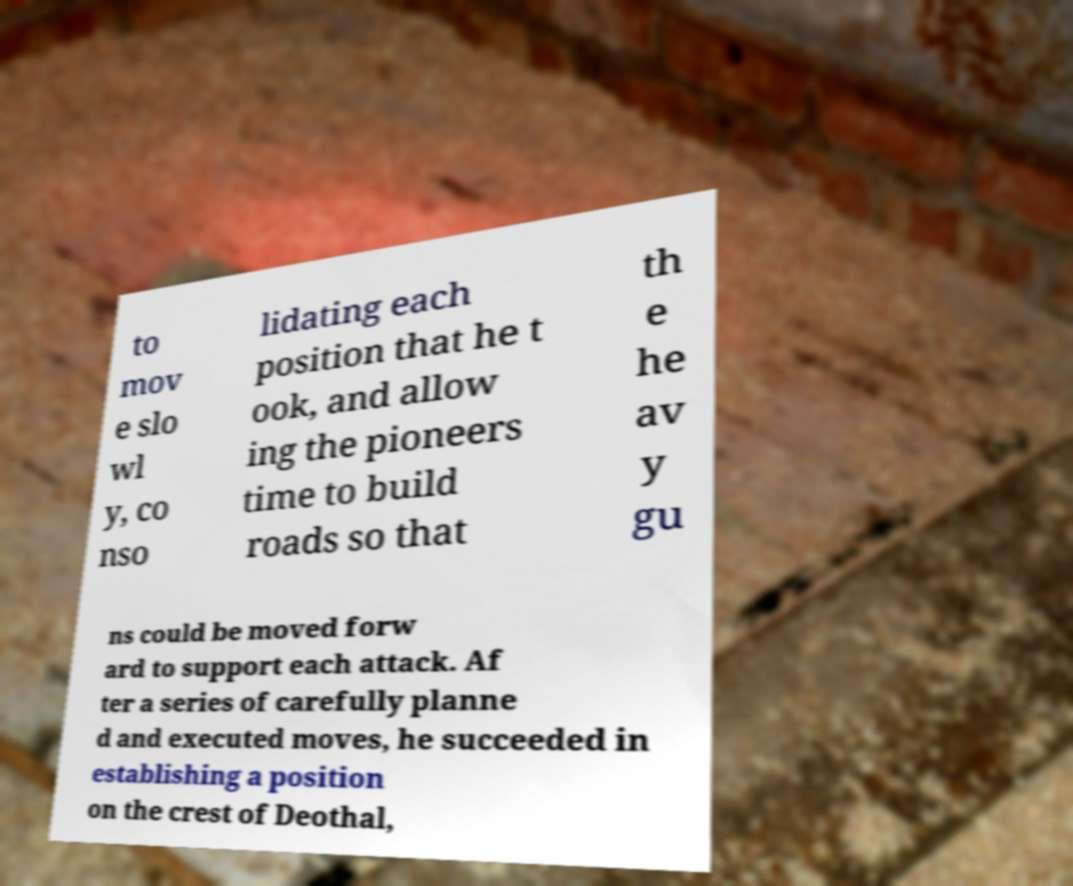What messages or text are displayed in this image? I need them in a readable, typed format. to mov e slo wl y, co nso lidating each position that he t ook, and allow ing the pioneers time to build roads so that th e he av y gu ns could be moved forw ard to support each attack. Af ter a series of carefully planne d and executed moves, he succeeded in establishing a position on the crest of Deothal, 